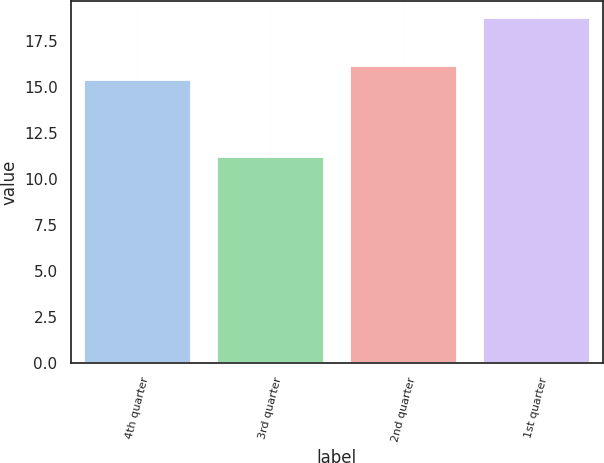Convert chart to OTSL. <chart><loc_0><loc_0><loc_500><loc_500><bar_chart><fcel>4th quarter<fcel>3rd quarter<fcel>2nd quarter<fcel>1st quarter<nl><fcel>15.38<fcel>11.22<fcel>16.13<fcel>18.76<nl></chart> 